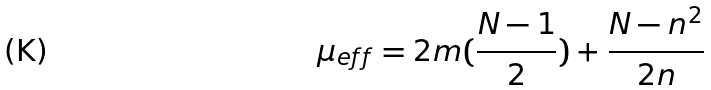Convert formula to latex. <formula><loc_0><loc_0><loc_500><loc_500>\mu _ { e f f } = 2 m ( \frac { N - 1 } { 2 } ) + \frac { N - n ^ { 2 } } { 2 n }</formula> 